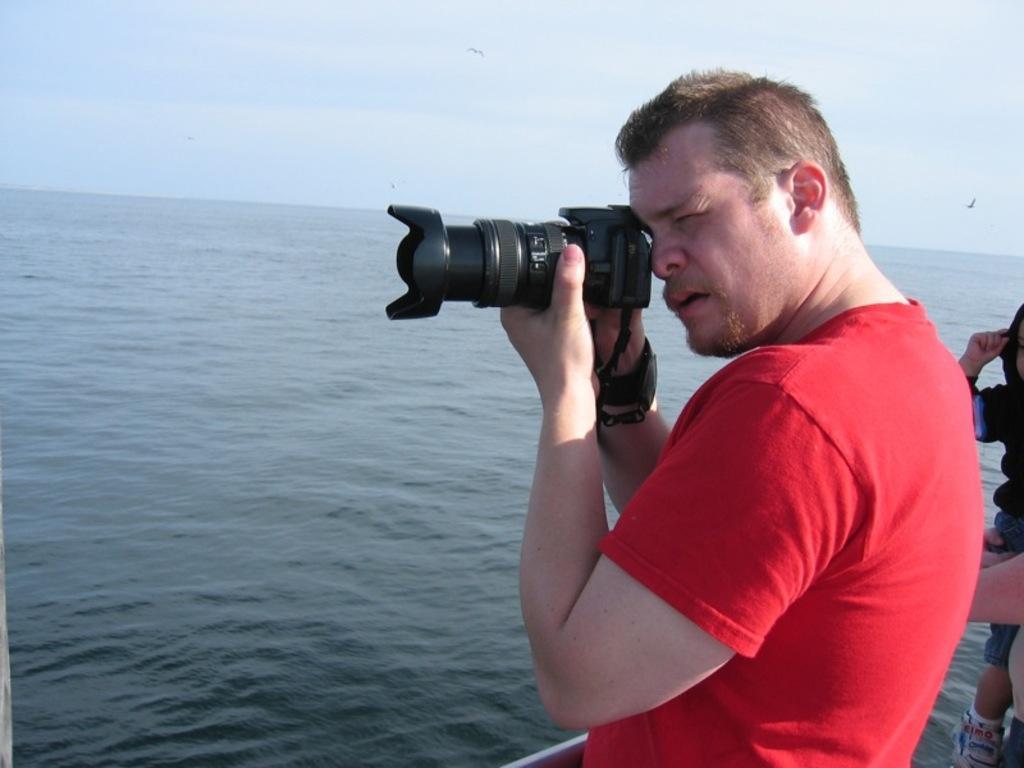Can you describe this image briefly? A person wearing a red t shirt is holding camera and taking picture. In the background there is water and sky. Also in the right a person is holding a child. 